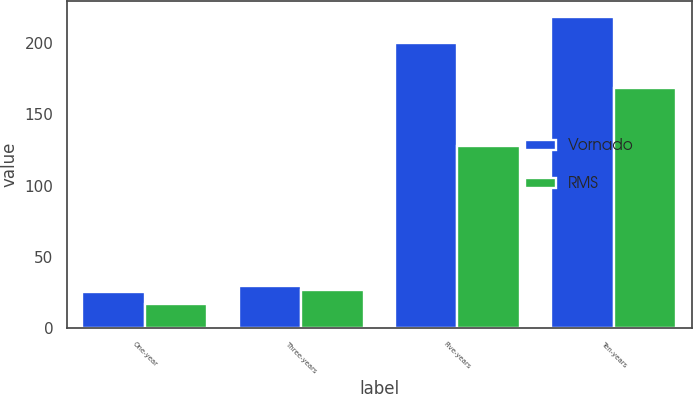Convert chart. <chart><loc_0><loc_0><loc_500><loc_500><stacked_bar_chart><ecel><fcel>One-year<fcel>Three-years<fcel>Five-years<fcel>Ten-years<nl><fcel>Vornado<fcel>25.5<fcel>29.7<fcel>199.8<fcel>218.2<nl><fcel>RMS<fcel>16.8<fcel>26.8<fcel>128<fcel>168.1<nl></chart> 